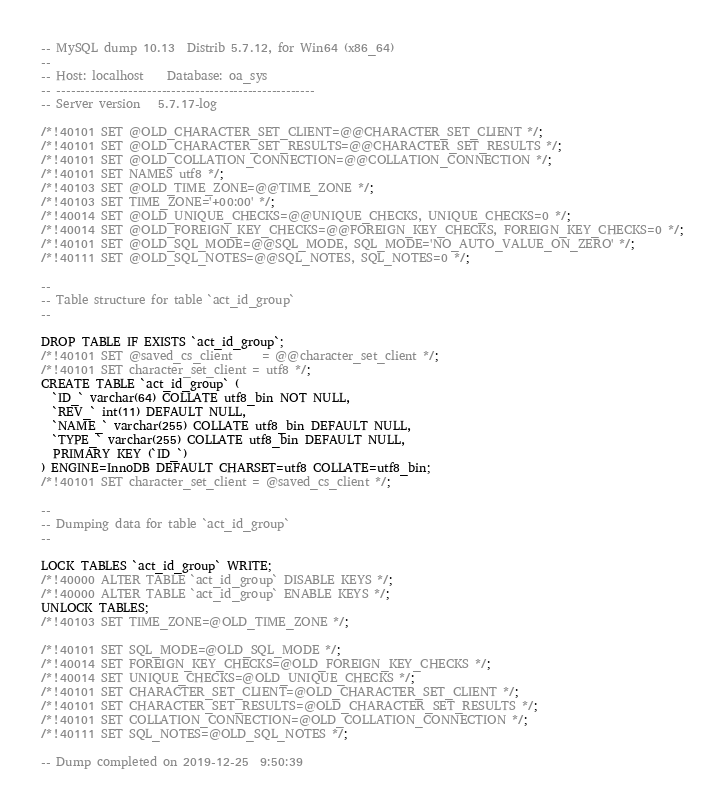<code> <loc_0><loc_0><loc_500><loc_500><_SQL_>-- MySQL dump 10.13  Distrib 5.7.12, for Win64 (x86_64)
--
-- Host: localhost    Database: oa_sys
-- ------------------------------------------------------
-- Server version	5.7.17-log

/*!40101 SET @OLD_CHARACTER_SET_CLIENT=@@CHARACTER_SET_CLIENT */;
/*!40101 SET @OLD_CHARACTER_SET_RESULTS=@@CHARACTER_SET_RESULTS */;
/*!40101 SET @OLD_COLLATION_CONNECTION=@@COLLATION_CONNECTION */;
/*!40101 SET NAMES utf8 */;
/*!40103 SET @OLD_TIME_ZONE=@@TIME_ZONE */;
/*!40103 SET TIME_ZONE='+00:00' */;
/*!40014 SET @OLD_UNIQUE_CHECKS=@@UNIQUE_CHECKS, UNIQUE_CHECKS=0 */;
/*!40014 SET @OLD_FOREIGN_KEY_CHECKS=@@FOREIGN_KEY_CHECKS, FOREIGN_KEY_CHECKS=0 */;
/*!40101 SET @OLD_SQL_MODE=@@SQL_MODE, SQL_MODE='NO_AUTO_VALUE_ON_ZERO' */;
/*!40111 SET @OLD_SQL_NOTES=@@SQL_NOTES, SQL_NOTES=0 */;

--
-- Table structure for table `act_id_group`
--

DROP TABLE IF EXISTS `act_id_group`;
/*!40101 SET @saved_cs_client     = @@character_set_client */;
/*!40101 SET character_set_client = utf8 */;
CREATE TABLE `act_id_group` (
  `ID_` varchar(64) COLLATE utf8_bin NOT NULL,
  `REV_` int(11) DEFAULT NULL,
  `NAME_` varchar(255) COLLATE utf8_bin DEFAULT NULL,
  `TYPE_` varchar(255) COLLATE utf8_bin DEFAULT NULL,
  PRIMARY KEY (`ID_`)
) ENGINE=InnoDB DEFAULT CHARSET=utf8 COLLATE=utf8_bin;
/*!40101 SET character_set_client = @saved_cs_client */;

--
-- Dumping data for table `act_id_group`
--

LOCK TABLES `act_id_group` WRITE;
/*!40000 ALTER TABLE `act_id_group` DISABLE KEYS */;
/*!40000 ALTER TABLE `act_id_group` ENABLE KEYS */;
UNLOCK TABLES;
/*!40103 SET TIME_ZONE=@OLD_TIME_ZONE */;

/*!40101 SET SQL_MODE=@OLD_SQL_MODE */;
/*!40014 SET FOREIGN_KEY_CHECKS=@OLD_FOREIGN_KEY_CHECKS */;
/*!40014 SET UNIQUE_CHECKS=@OLD_UNIQUE_CHECKS */;
/*!40101 SET CHARACTER_SET_CLIENT=@OLD_CHARACTER_SET_CLIENT */;
/*!40101 SET CHARACTER_SET_RESULTS=@OLD_CHARACTER_SET_RESULTS */;
/*!40101 SET COLLATION_CONNECTION=@OLD_COLLATION_CONNECTION */;
/*!40111 SET SQL_NOTES=@OLD_SQL_NOTES */;

-- Dump completed on 2019-12-25  9:50:39
</code> 